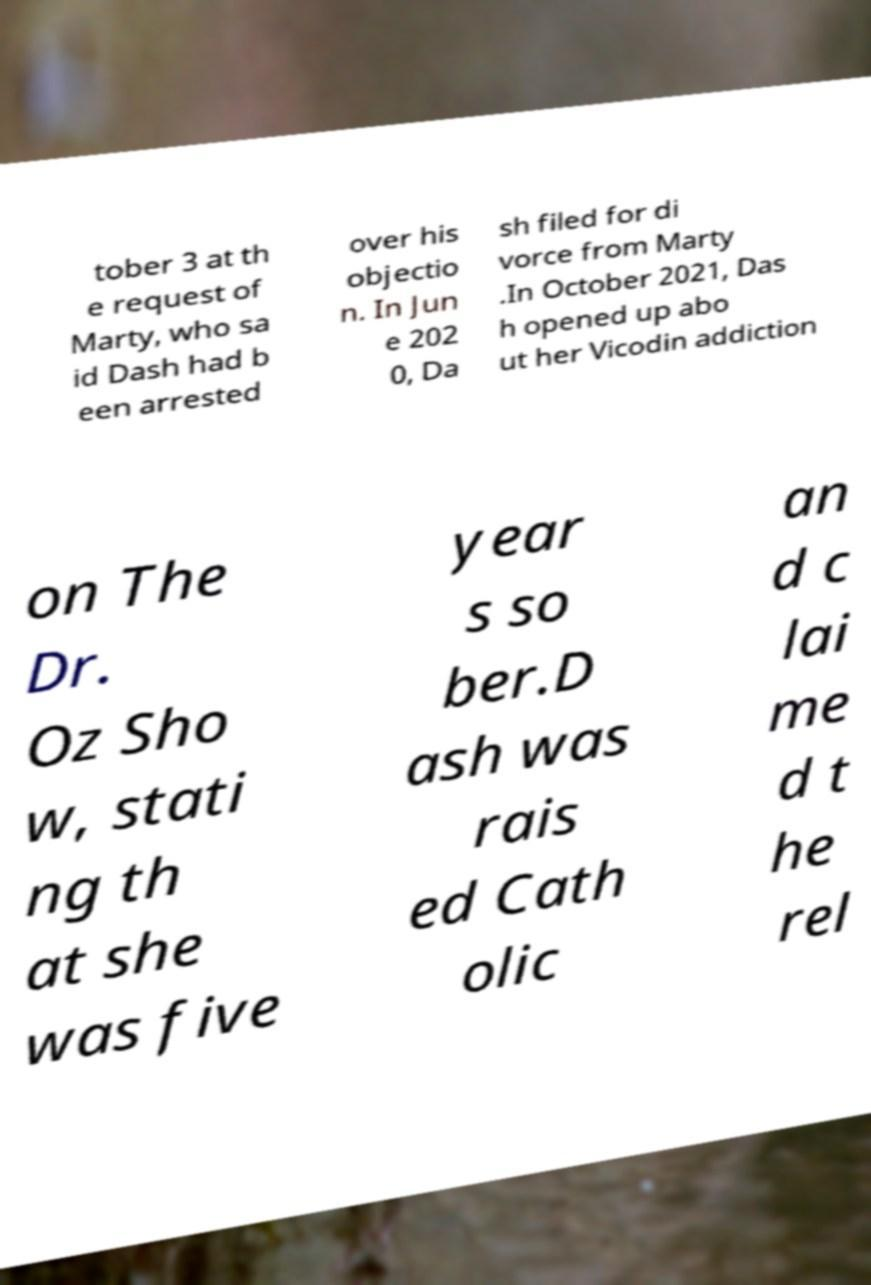Can you accurately transcribe the text from the provided image for me? tober 3 at th e request of Marty, who sa id Dash had b een arrested over his objectio n. In Jun e 202 0, Da sh filed for di vorce from Marty .In October 2021, Das h opened up abo ut her Vicodin addiction on The Dr. Oz Sho w, stati ng th at she was five year s so ber.D ash was rais ed Cath olic an d c lai me d t he rel 